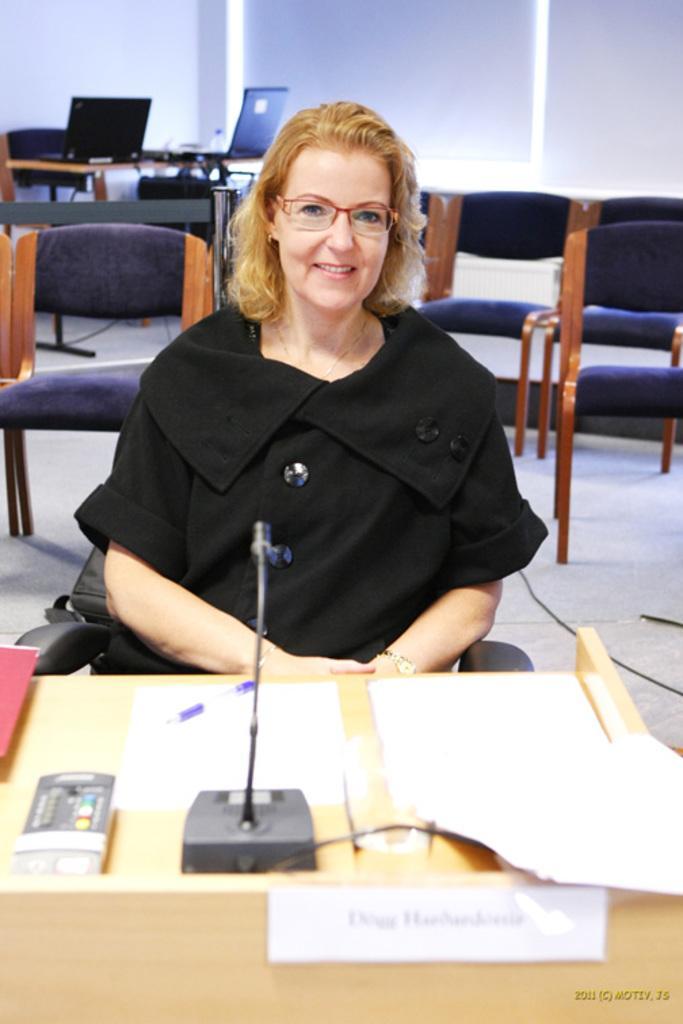How would you summarize this image in a sentence or two? In this picture we can see a woman sitting on the chair in front of table. This is the mike and on back of her there are some chairs. This is the floor and there is a wall. And these are the systems. 